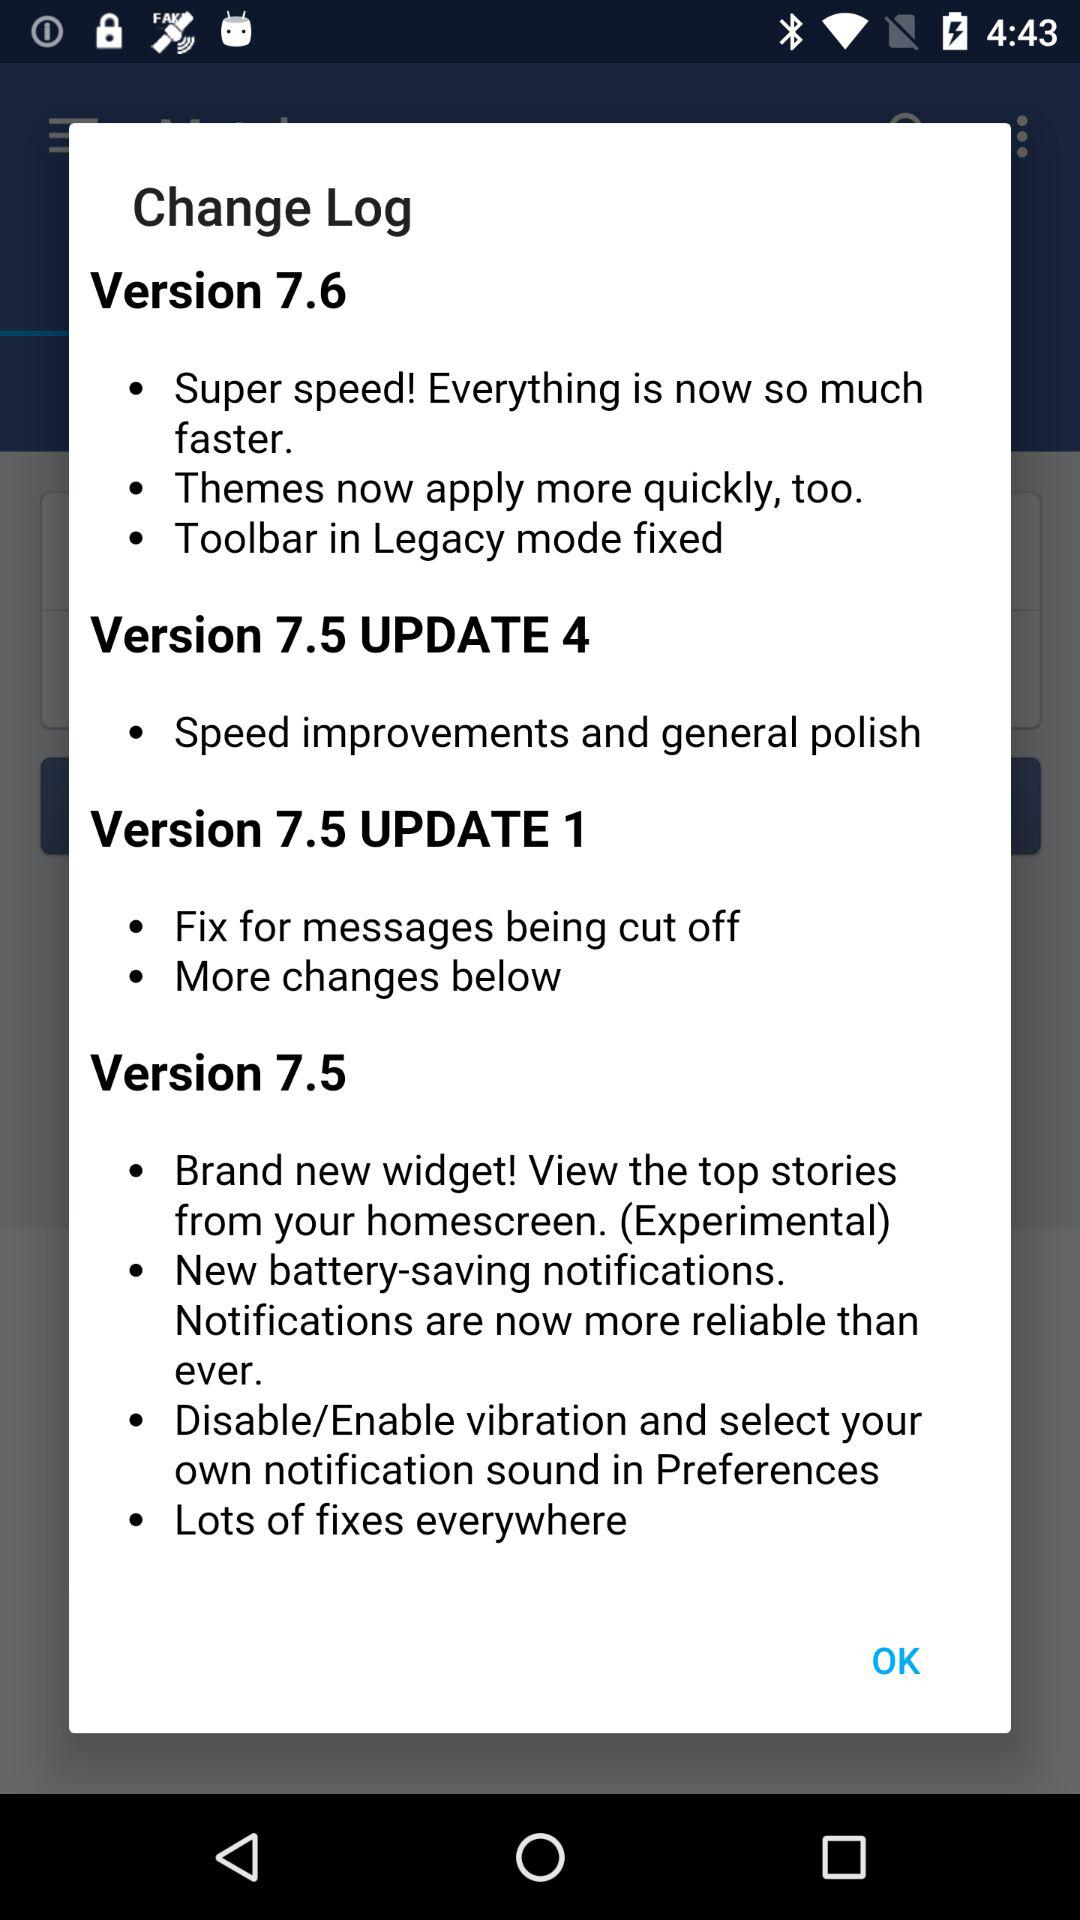How many versions are there in this change log?
Answer the question using a single word or phrase. 4 